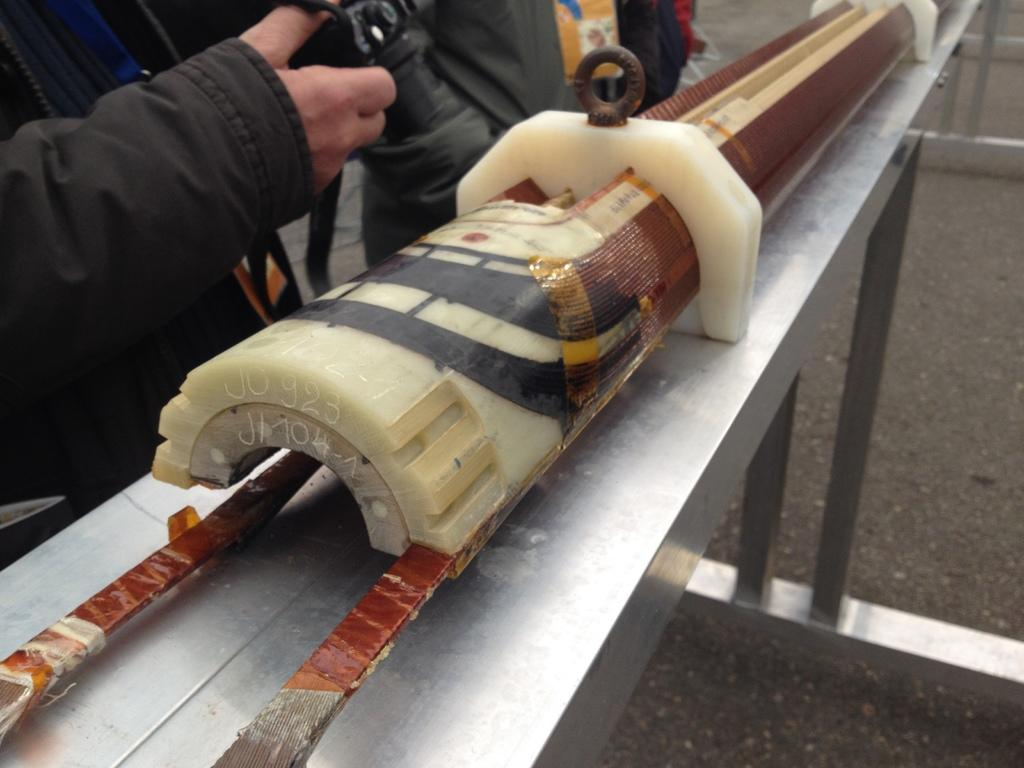What is the main object on the table in the image? There is an equipment on a table in the image. Can you describe the people standing beside the equipment? There are people standing beside the equipment in the image. What word is being used to describe the activity taking place in the image? There is no specific word mentioned in the image to describe the activity. Can you see a tramp in the image? There is no tramp present in the image. 